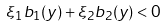Convert formula to latex. <formula><loc_0><loc_0><loc_500><loc_500>\xi _ { 1 } b _ { 1 } ( y ) + \xi _ { 2 } b _ { 2 } ( y ) < 0</formula> 